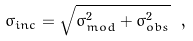<formula> <loc_0><loc_0><loc_500><loc_500>\sigma _ { i n c } = \sqrt { \sigma _ { m o d } ^ { 2 } + \sigma _ { o b s } ^ { 2 } } \ ,</formula> 